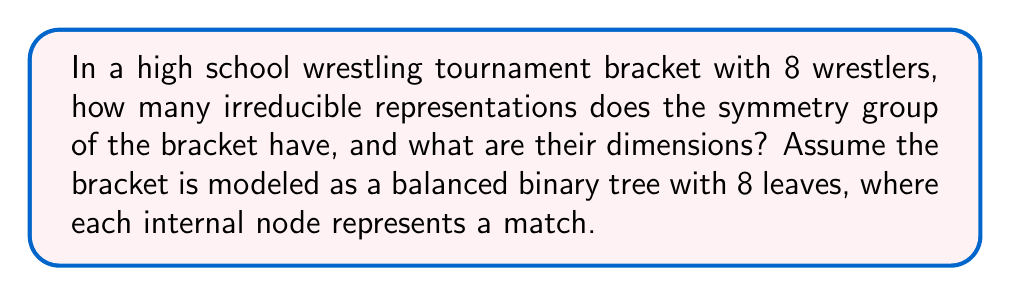Give your solution to this math problem. Let's approach this step-by-step, relating it to our wrestling tournament:

1) First, we need to identify the symmetry group of the tournament bracket. The bracket can be modeled as a balanced binary tree with 8 leaves (wrestlers). The symmetry group of this structure is isomorphic to the wreath product $S_2 \wr S_3$, where $S_n$ is the symmetric group on $n$ elements.

2) The order of this group is:
   $$|S_2 \wr S_3| = 2^3 \cdot 3! = 8 \cdot 6 = 48$$

3) To find the irreducible representations, we can use the method of inducing representations from subgroups. The subgroups we'll use are:
   - $H_1 = S_2 \times S_2 \times S_2$ (permutations at each level)
   - $H_2 = S_3$ (permutations of the three levels)

4) $H_1$ has 8 irreducible representations, all 1-dimensional.

5) $H_2$ (which is $S_3$) has 3 irreducible representations:
   - The trivial representation (dimension 1)
   - The sign representation (dimension 1)
   - The standard representation (dimension 2)

6) Inducing these representations to the full group and decomposing them, we get:
   - 4 representations of dimension 1
   - 2 representations of dimension 2
   - 4 representations of dimension 3
   - 1 representation of dimension 4

7) In total, this gives us 11 irreducible representations.

This structure mirrors how in a wrestling tournament, we have different levels of competition (preliminary rounds, semifinals, finals) and different ways the matches can play out while maintaining the overall bracket structure.
Answer: 11 irreducible representations: 4 of dimension 1, 2 of dimension 2, 4 of dimension 3, and 1 of dimension 4. 